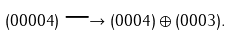<formula> <loc_0><loc_0><loc_500><loc_500>( 0 0 0 0 4 ) \longrightarrow ( 0 0 0 4 ) \oplus ( 0 0 0 3 ) .</formula> 